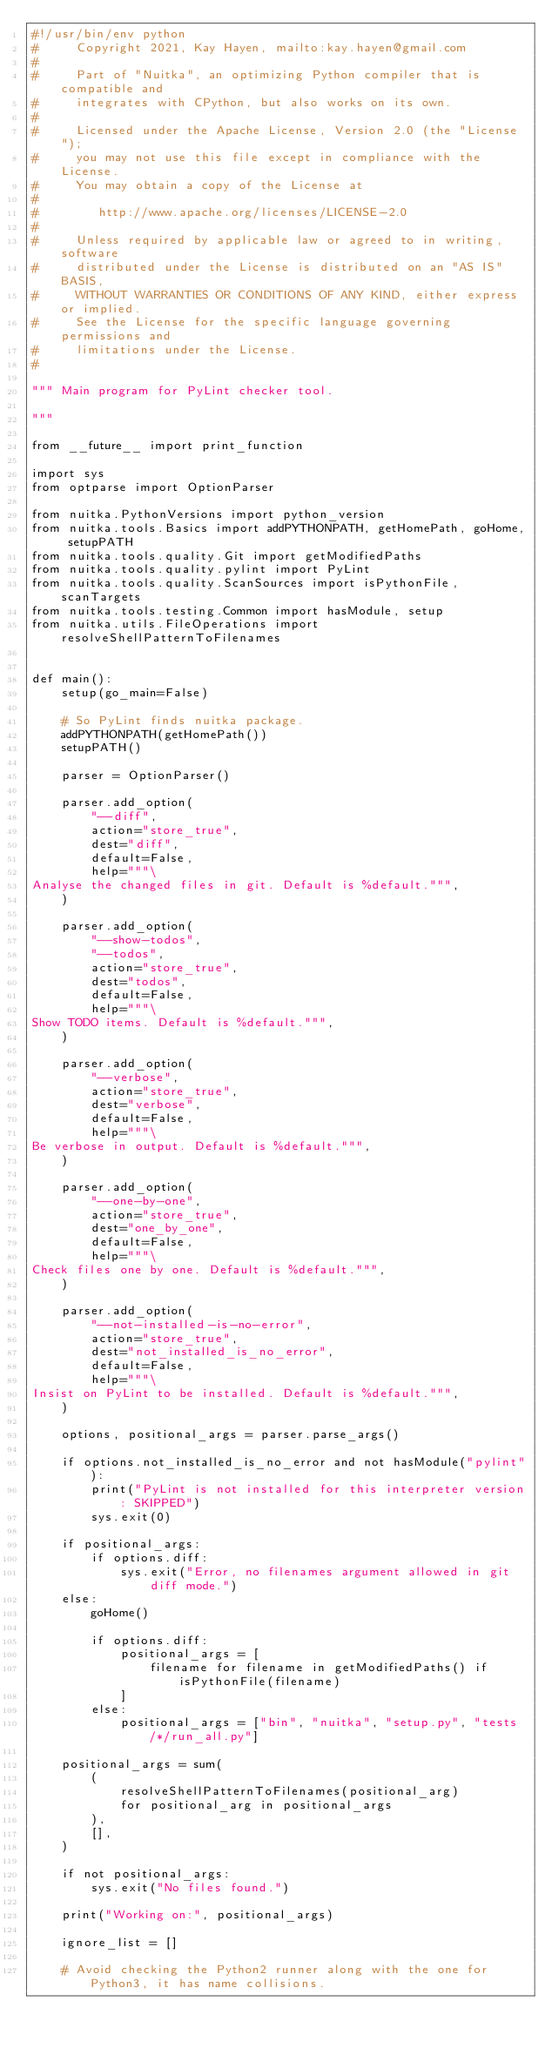Convert code to text. <code><loc_0><loc_0><loc_500><loc_500><_Python_>#!/usr/bin/env python
#     Copyright 2021, Kay Hayen, mailto:kay.hayen@gmail.com
#
#     Part of "Nuitka", an optimizing Python compiler that is compatible and
#     integrates with CPython, but also works on its own.
#
#     Licensed under the Apache License, Version 2.0 (the "License");
#     you may not use this file except in compliance with the License.
#     You may obtain a copy of the License at
#
#        http://www.apache.org/licenses/LICENSE-2.0
#
#     Unless required by applicable law or agreed to in writing, software
#     distributed under the License is distributed on an "AS IS" BASIS,
#     WITHOUT WARRANTIES OR CONDITIONS OF ANY KIND, either express or implied.
#     See the License for the specific language governing permissions and
#     limitations under the License.
#

""" Main program for PyLint checker tool.

"""

from __future__ import print_function

import sys
from optparse import OptionParser

from nuitka.PythonVersions import python_version
from nuitka.tools.Basics import addPYTHONPATH, getHomePath, goHome, setupPATH
from nuitka.tools.quality.Git import getModifiedPaths
from nuitka.tools.quality.pylint import PyLint
from nuitka.tools.quality.ScanSources import isPythonFile, scanTargets
from nuitka.tools.testing.Common import hasModule, setup
from nuitka.utils.FileOperations import resolveShellPatternToFilenames


def main():
    setup(go_main=False)

    # So PyLint finds nuitka package.
    addPYTHONPATH(getHomePath())
    setupPATH()

    parser = OptionParser()

    parser.add_option(
        "--diff",
        action="store_true",
        dest="diff",
        default=False,
        help="""\
Analyse the changed files in git. Default is %default.""",
    )

    parser.add_option(
        "--show-todos",
        "--todos",
        action="store_true",
        dest="todos",
        default=False,
        help="""\
Show TODO items. Default is %default.""",
    )

    parser.add_option(
        "--verbose",
        action="store_true",
        dest="verbose",
        default=False,
        help="""\
Be verbose in output. Default is %default.""",
    )

    parser.add_option(
        "--one-by-one",
        action="store_true",
        dest="one_by_one",
        default=False,
        help="""\
Check files one by one. Default is %default.""",
    )

    parser.add_option(
        "--not-installed-is-no-error",
        action="store_true",
        dest="not_installed_is_no_error",
        default=False,
        help="""\
Insist on PyLint to be installed. Default is %default.""",
    )

    options, positional_args = parser.parse_args()

    if options.not_installed_is_no_error and not hasModule("pylint"):
        print("PyLint is not installed for this interpreter version: SKIPPED")
        sys.exit(0)

    if positional_args:
        if options.diff:
            sys.exit("Error, no filenames argument allowed in git diff mode.")
    else:
        goHome()

        if options.diff:
            positional_args = [
                filename for filename in getModifiedPaths() if isPythonFile(filename)
            ]
        else:
            positional_args = ["bin", "nuitka", "setup.py", "tests/*/run_all.py"]

    positional_args = sum(
        (
            resolveShellPatternToFilenames(positional_arg)
            for positional_arg in positional_args
        ),
        [],
    )

    if not positional_args:
        sys.exit("No files found.")

    print("Working on:", positional_args)

    ignore_list = []

    # Avoid checking the Python2 runner along with the one for Python3, it has name collisions.</code> 